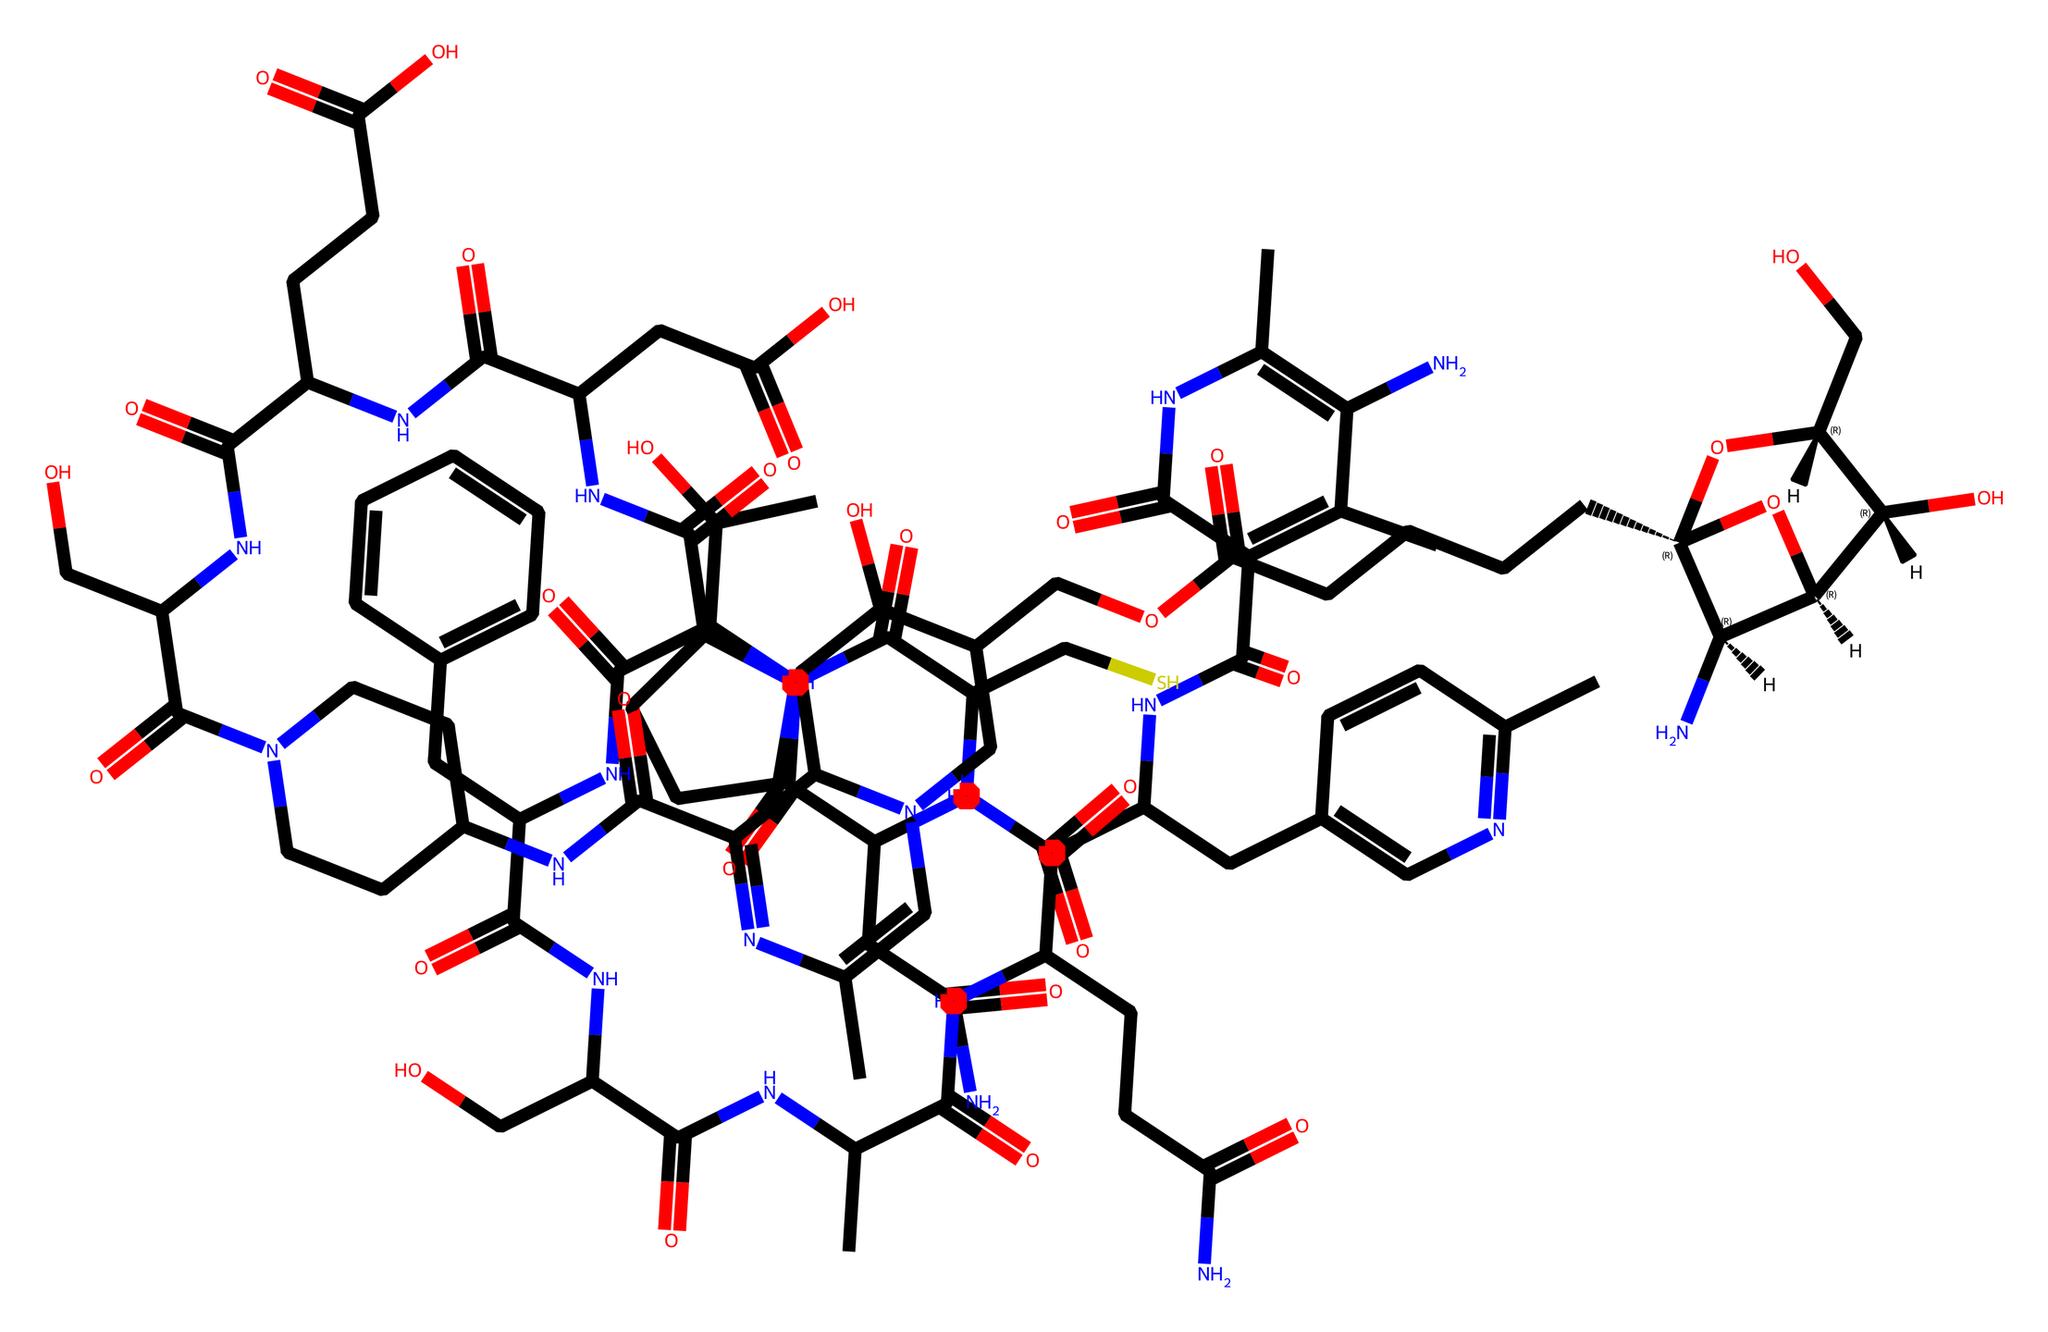What is the primary function of vitamin B12? Vitamin B12 is crucial for red blood cell formation, neurological function, and DNA synthesis.
Answer: red blood cell formation How many nitrogen atoms are present in the structure? By analyzing the SMILES representation, it is evident that there are multiple nitrogen (N) atoms throughout the structure. Counting them shows a total of six nitrogen atoms.
Answer: six What type of molecule is vitamin B12 classified as? Vitamin B12 is classified as a vitamin, which is an organic compound essential for normal growth and nutrition, typically required in small quantities in the diet.
Answer: vitamin How many carbon atoms are found in the structure? Counting the carbon (C) atoms in the SMILES representation reveals a total of 25 carbon atoms present in the molecule.
Answer: twenty-five Which functional group is commonly associated with vitamins like B12? The presence of amide (given by -C(=O)N-) and hydroxyl (-OH) groups signifies its classification as a vitamin, as they are typical in vitamin structures for their functional roles in the body.
Answer: amide and hydroxyl groups What does the presence of multiple carbonyl (C=O) groups suggest about this vitamin's properties? The numerous carbonyl groups indicate that vitamin B12 has significant potential for forming coordinate bonds, which are essential for its biological activity and interaction with proteins.
Answer: coordinate bonds What role does vitamin B12 play for nomadic Mongolian herders? For nomadic Mongolian herders, vitamin B12 is essential for maintaining energy levels, cognitive function, and overall health, which is vital given their physically demanding lifestyle.
Answer: energy levels and cognitive function 